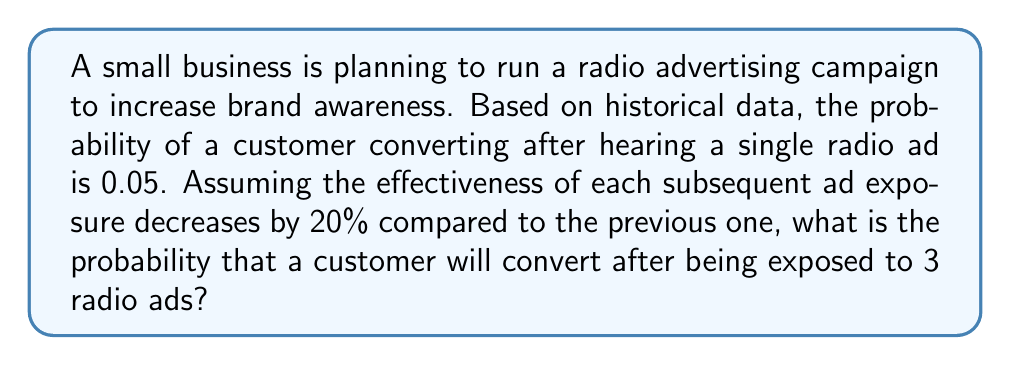Show me your answer to this math problem. Let's approach this step-by-step:

1) First, we need to calculate the probability of conversion for each ad exposure:

   1st ad: $p_1 = 0.05$
   2nd ad: $p_2 = 0.05 \times 0.8 = 0.04$
   3rd ad: $p_3 = 0.04 \times 0.8 = 0.032$

2) Now, we need to calculate the probability that a customer converts after being exposed to all 3 ads. This is equivalent to the probability that the customer doesn't convert after the first two ads, but does convert after the third ad, plus the probability of converting after the first or second ad.

3) Let's calculate the probability of not converting after each ad:

   1st ad: $1 - p_1 = 0.95$
   2nd ad: $1 - p_2 = 0.96$
   3rd ad: $1 - p_3 = 0.968$

4) The probability of converting after exactly the 3rd ad is:

   $0.95 \times 0.96 \times 0.032 = 0.029184$

5) The probability of converting after the 1st or 2nd ad is:

   $0.05 + (0.95 \times 0.04) = 0.088$

6) Therefore, the total probability of converting after being exposed to 3 ads is:

   $0.029184 + 0.088 = 0.117184$
Answer: The probability that a customer will convert after being exposed to 3 radio ads is approximately $0.1172$ or $11.72\%$. 